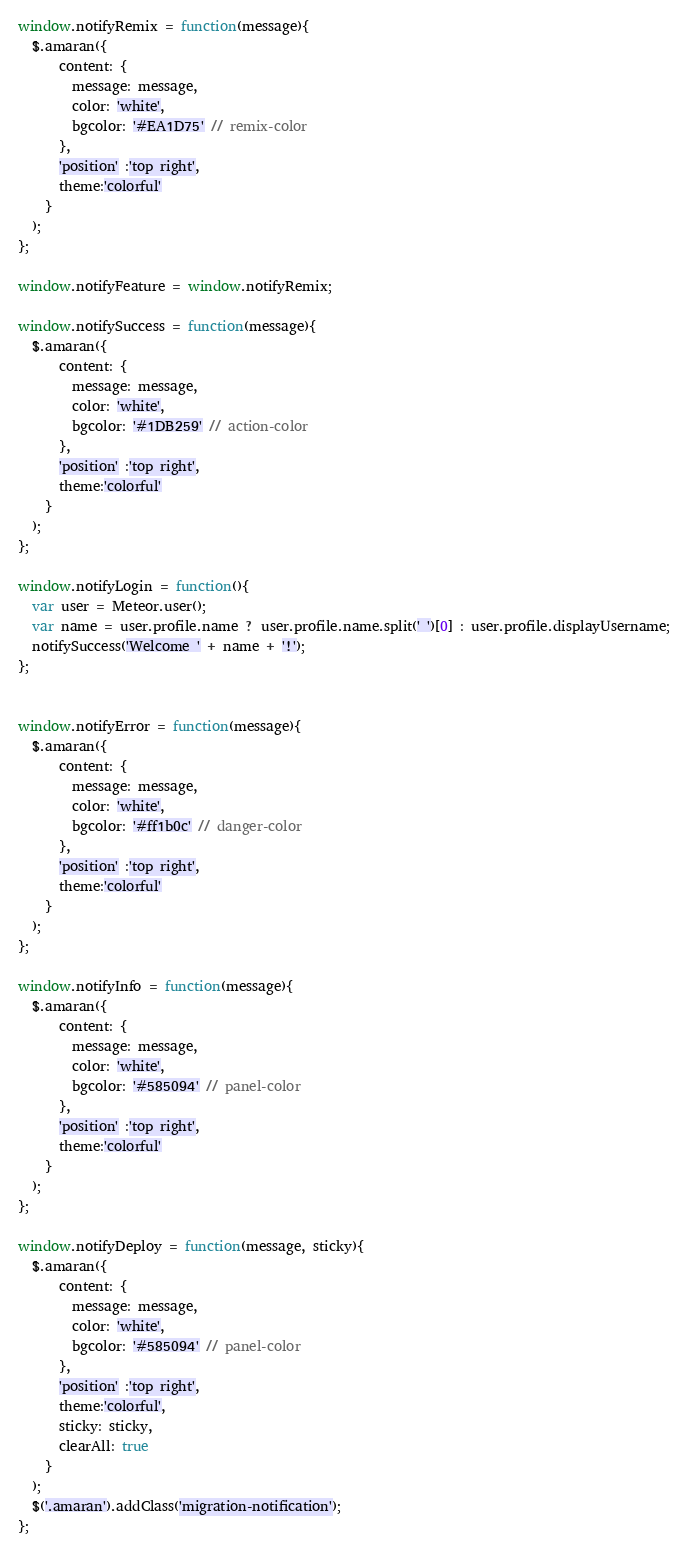Convert code to text. <code><loc_0><loc_0><loc_500><loc_500><_JavaScript_>window.notifyRemix = function(message){
  $.amaran({
      content: {
        message: message,
        color: 'white',
        bgcolor: '#EA1D75' // remix-color
      },
      'position' :'top right',
      theme:'colorful'
    }
  );
};

window.notifyFeature = window.notifyRemix;

window.notifySuccess = function(message){
  $.amaran({
      content: {
        message: message,
        color: 'white',
        bgcolor: '#1DB259' // action-color
      },
      'position' :'top right',
      theme:'colorful'
    }
  );
};

window.notifyLogin = function(){
  var user = Meteor.user();
  var name = user.profile.name ? user.profile.name.split(' ')[0] : user.profile.displayUsername;
  notifySuccess('Welcome ' + name + '!');
};


window.notifyError = function(message){
  $.amaran({
      content: {
        message: message,
        color: 'white',
        bgcolor: '#ff1b0c' // danger-color
      },
      'position' :'top right',
      theme:'colorful'
    }
  );
};

window.notifyInfo = function(message){
  $.amaran({
      content: {
        message: message,
        color: 'white',
        bgcolor: '#585094' // panel-color
      },
      'position' :'top right',
      theme:'colorful'
    }
  );
};

window.notifyDeploy = function(message, sticky){
  $.amaran({
      content: {
        message: message,
        color: 'white',
        bgcolor: '#585094' // panel-color
      },
      'position' :'top right',
      theme:'colorful',
      sticky: sticky,
      clearAll: true
    }
  );
  $('.amaran').addClass('migration-notification');
};
</code> 